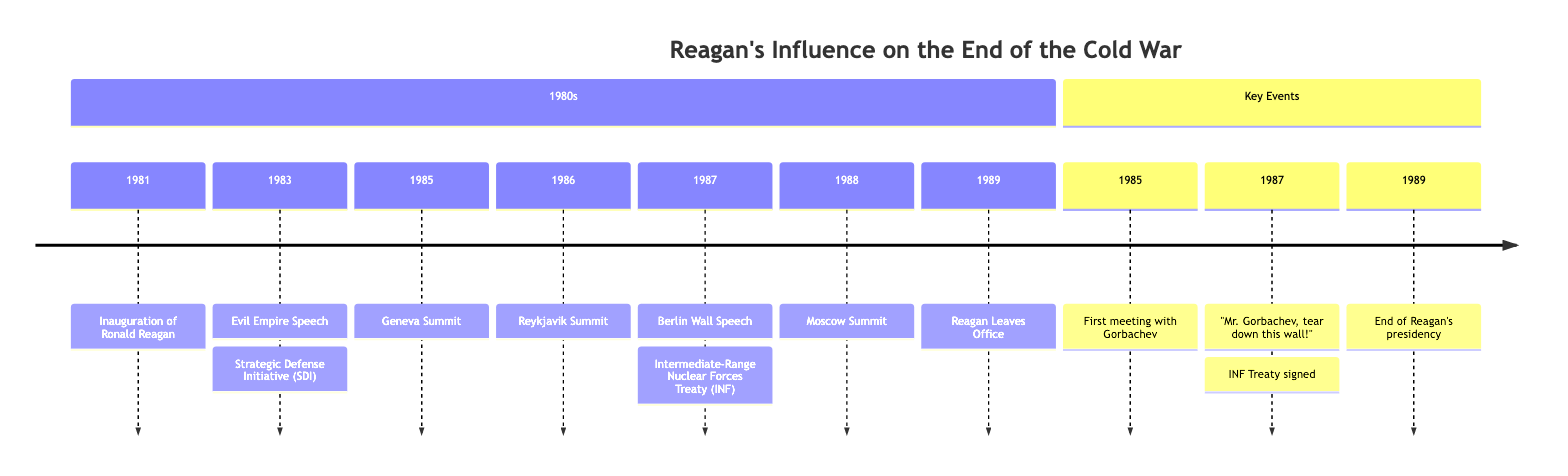What year did Reagan deliver the "Evil Empire" speech? The diagram shows that the "Evil Empire Speech" event is listed under the year 1983, meaning that is when Reagan delivered that speech.
Answer: 1983 What significant treaty was signed in 1987? The diagram includes the "Intermediate-Range Nuclear Forces Treaty (INF)" for the year 1987, indicating that this was a significant treaty signed that year.
Answer: INF Treaty How many summits with Gorbachev are listed in the timeline? By scanning through the timeline, there are three mentions of summits with Gorbachev: Geneva Summit (1985), Reykjavik Summit (1986), and Moscow Summit (1988), totaling three summits.
Answer: 3 What was the main theme of Reagan's 1987 Berlin Wall Speech? The Berlin Wall Speech in 1987 famously included the demand, "Mr. Gorbachev, tear down this wall!", which embodies the main theme of the speech urging the dismantling of the wall.
Answer: Tear down this wall! When did Reagan's presidency end? According to the timeline, Reagan completes his second term in 1989, indicating the end of his presidency that year.
Answer: 1989 Which event marks the first meeting between Reagan and Gorbachev? The timeline mentions the "Geneva Summit" in 1985 as the first occasion Reagan met with Gorbachev, making it the initial interaction between the two leaders.
Answer: Geneva Summit What initiative did Reagan announce in 1983? In the year 1983, the timeline indicates that Reagan announced the "Strategic Defense Initiative (SDI)", highlighting a significant Cold War development.
Answer: Strategic Defense Initiative What event occurred immediately before the signing of the INF Treaty? Before the signing of the INF Treaty in 1987, the preceding event listed is the "Berlin Wall Speech", indicating it took place right before the treaty signing that year.
Answer: Berlin Wall Speech 